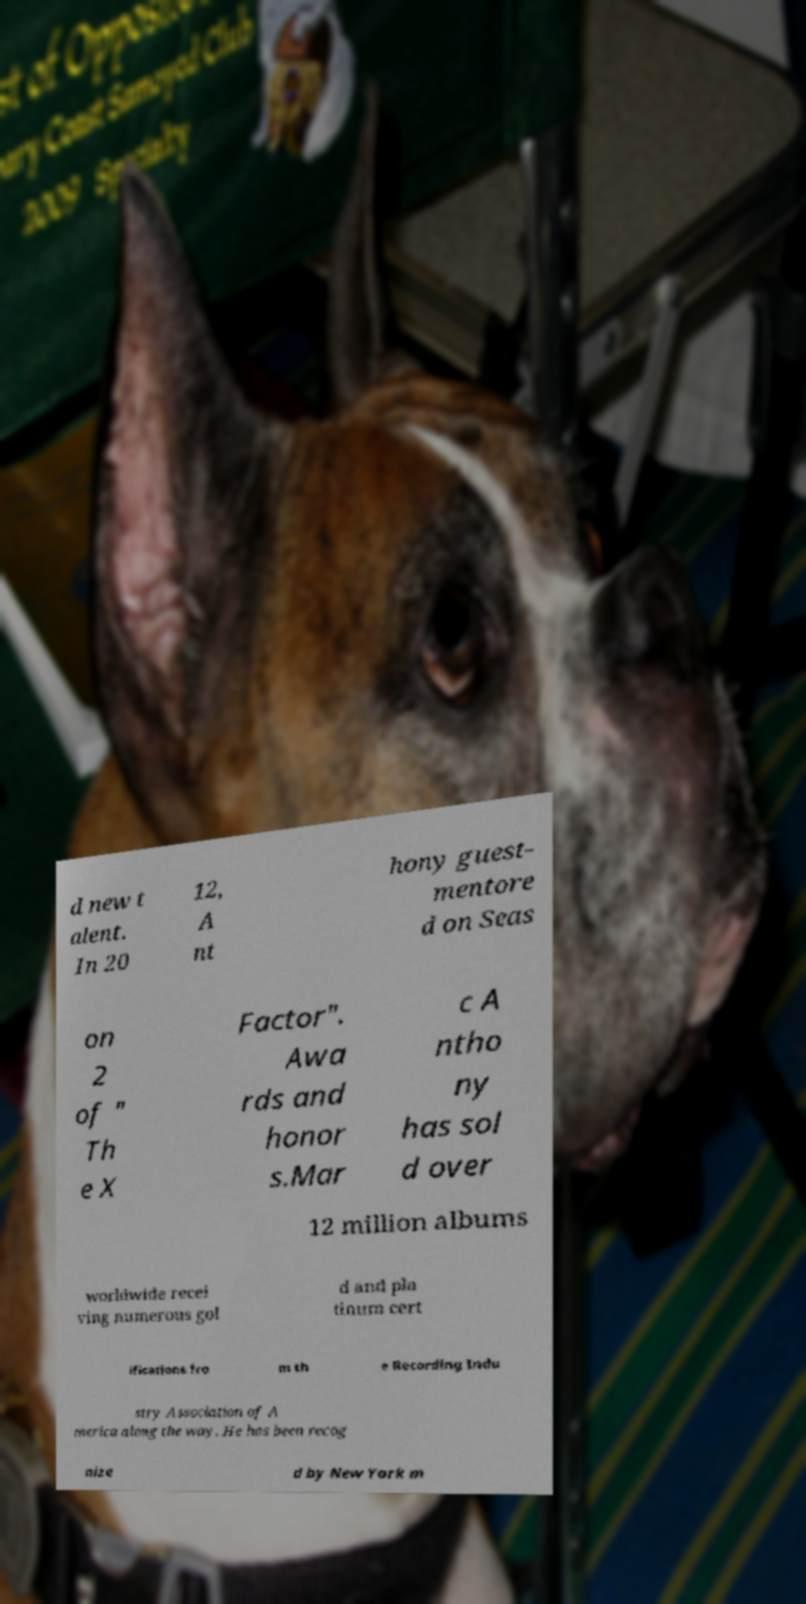Can you read and provide the text displayed in the image?This photo seems to have some interesting text. Can you extract and type it out for me? d new t alent. In 20 12, A nt hony guest- mentore d on Seas on 2 of " Th e X Factor". Awa rds and honor s.Mar c A ntho ny has sol d over 12 million albums worldwide recei ving numerous gol d and pla tinum cert ifications fro m th e Recording Indu stry Association of A merica along the way. He has been recog nize d by New York m 